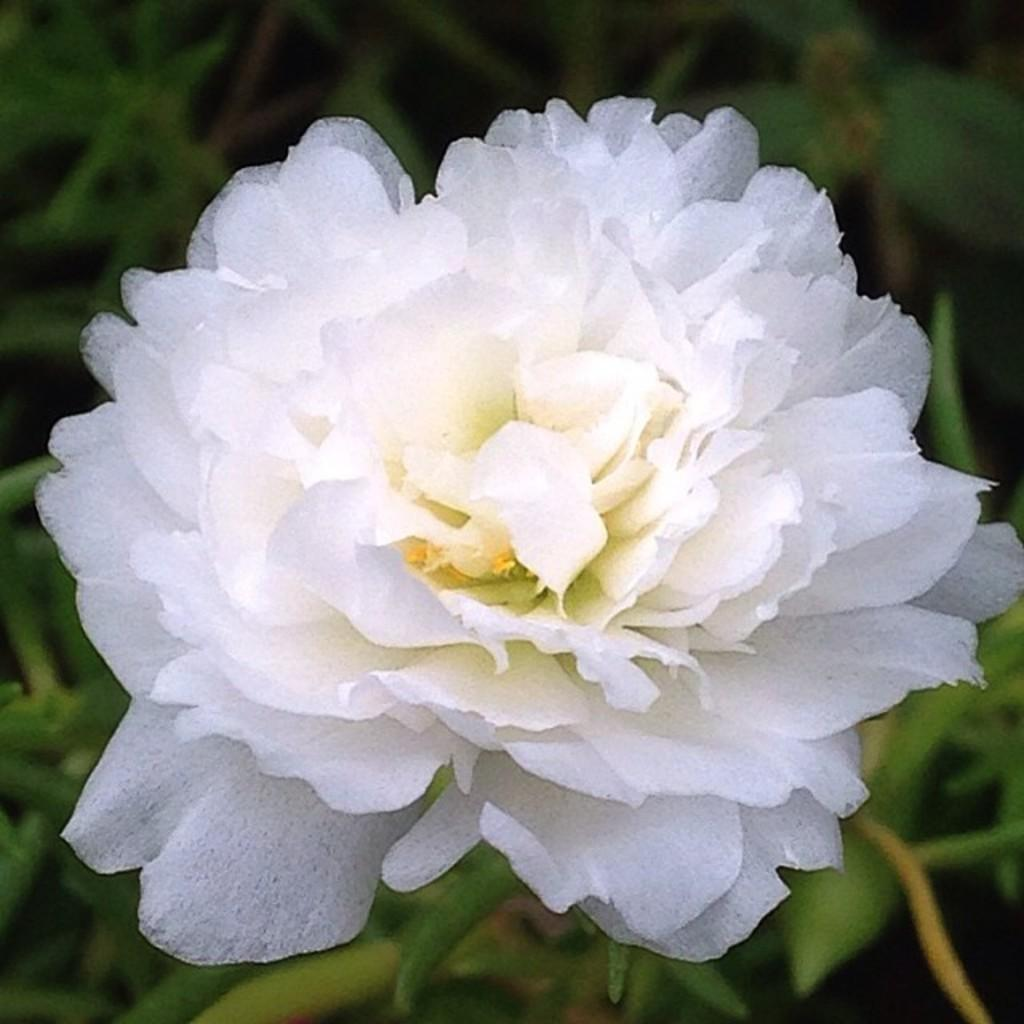What is the main subject in the foreground of the image? There is a white color flower in the foreground of the image. What else can be seen in the foreground of the image? The green leaves of a plant are in the foreground of the image. What is visible in the background of the image? There are plants visible in the background of the image. Where is the playground located in the image? There is no playground present in the image. What type of agreement is being signed by the plants in the image? There are no plants signing any agreements in the image; it features a white flower and green leaves in the foreground, with additional plants in the background. 